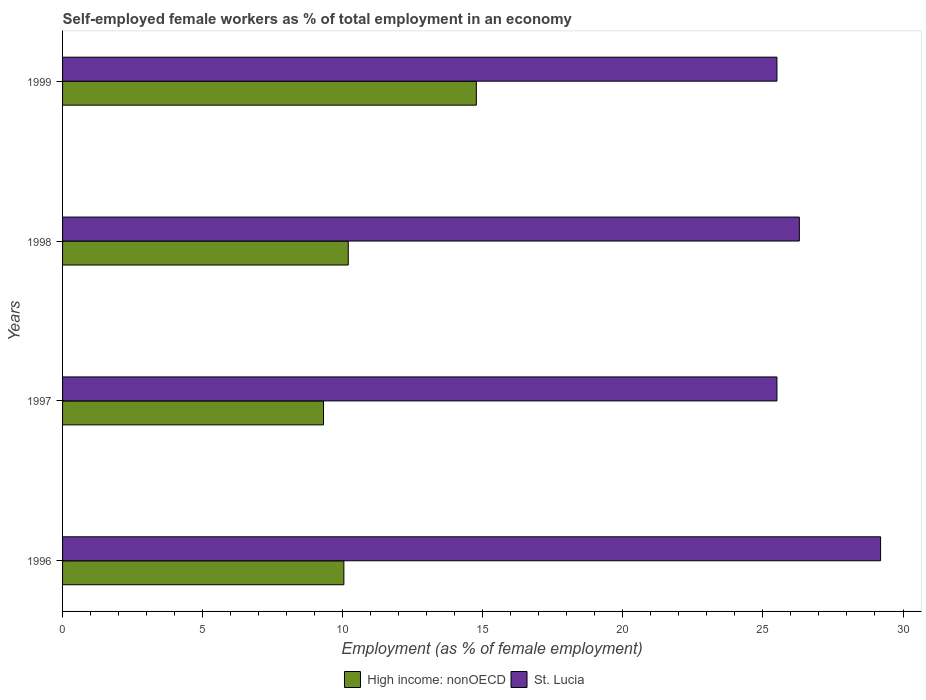How many groups of bars are there?
Ensure brevity in your answer.  4. Are the number of bars on each tick of the Y-axis equal?
Keep it short and to the point. Yes. How many bars are there on the 2nd tick from the bottom?
Give a very brief answer. 2. What is the label of the 3rd group of bars from the top?
Provide a short and direct response. 1997. What is the percentage of self-employed female workers in High income: nonOECD in 1998?
Your answer should be very brief. 10.2. Across all years, what is the maximum percentage of self-employed female workers in High income: nonOECD?
Offer a terse response. 14.77. Across all years, what is the minimum percentage of self-employed female workers in St. Lucia?
Your answer should be very brief. 25.5. What is the total percentage of self-employed female workers in High income: nonOECD in the graph?
Give a very brief answer. 44.33. What is the difference between the percentage of self-employed female workers in High income: nonOECD in 1997 and that in 1998?
Provide a succinct answer. -0.88. What is the difference between the percentage of self-employed female workers in High income: nonOECD in 1996 and the percentage of self-employed female workers in St. Lucia in 1998?
Ensure brevity in your answer.  -16.26. What is the average percentage of self-employed female workers in St. Lucia per year?
Provide a short and direct response. 26.62. In the year 1996, what is the difference between the percentage of self-employed female workers in High income: nonOECD and percentage of self-employed female workers in St. Lucia?
Make the answer very short. -19.16. In how many years, is the percentage of self-employed female workers in St. Lucia greater than 20 %?
Keep it short and to the point. 4. What is the ratio of the percentage of self-employed female workers in St. Lucia in 1996 to that in 1999?
Provide a succinct answer. 1.15. Is the difference between the percentage of self-employed female workers in High income: nonOECD in 1996 and 1999 greater than the difference between the percentage of self-employed female workers in St. Lucia in 1996 and 1999?
Give a very brief answer. No. What is the difference between the highest and the second highest percentage of self-employed female workers in St. Lucia?
Make the answer very short. 2.9. What is the difference between the highest and the lowest percentage of self-employed female workers in High income: nonOECD?
Ensure brevity in your answer.  5.46. In how many years, is the percentage of self-employed female workers in St. Lucia greater than the average percentage of self-employed female workers in St. Lucia taken over all years?
Make the answer very short. 1. Is the sum of the percentage of self-employed female workers in St. Lucia in 1998 and 1999 greater than the maximum percentage of self-employed female workers in High income: nonOECD across all years?
Make the answer very short. Yes. What does the 1st bar from the top in 1997 represents?
Make the answer very short. St. Lucia. What does the 2nd bar from the bottom in 1997 represents?
Give a very brief answer. St. Lucia. Are all the bars in the graph horizontal?
Make the answer very short. Yes. How many years are there in the graph?
Ensure brevity in your answer.  4. Does the graph contain any zero values?
Give a very brief answer. No. Does the graph contain grids?
Ensure brevity in your answer.  No. How many legend labels are there?
Your answer should be very brief. 2. How are the legend labels stacked?
Make the answer very short. Horizontal. What is the title of the graph?
Make the answer very short. Self-employed female workers as % of total employment in an economy. What is the label or title of the X-axis?
Make the answer very short. Employment (as % of female employment). What is the Employment (as % of female employment) of High income: nonOECD in 1996?
Offer a very short reply. 10.04. What is the Employment (as % of female employment) of St. Lucia in 1996?
Provide a succinct answer. 29.2. What is the Employment (as % of female employment) of High income: nonOECD in 1997?
Your response must be concise. 9.31. What is the Employment (as % of female employment) in St. Lucia in 1997?
Give a very brief answer. 25.5. What is the Employment (as % of female employment) in High income: nonOECD in 1998?
Your answer should be very brief. 10.2. What is the Employment (as % of female employment) of St. Lucia in 1998?
Give a very brief answer. 26.3. What is the Employment (as % of female employment) of High income: nonOECD in 1999?
Your answer should be compact. 14.77. What is the Employment (as % of female employment) of St. Lucia in 1999?
Offer a terse response. 25.5. Across all years, what is the maximum Employment (as % of female employment) of High income: nonOECD?
Provide a short and direct response. 14.77. Across all years, what is the maximum Employment (as % of female employment) of St. Lucia?
Provide a short and direct response. 29.2. Across all years, what is the minimum Employment (as % of female employment) in High income: nonOECD?
Keep it short and to the point. 9.31. Across all years, what is the minimum Employment (as % of female employment) in St. Lucia?
Offer a very short reply. 25.5. What is the total Employment (as % of female employment) in High income: nonOECD in the graph?
Provide a succinct answer. 44.33. What is the total Employment (as % of female employment) of St. Lucia in the graph?
Offer a very short reply. 106.5. What is the difference between the Employment (as % of female employment) of High income: nonOECD in 1996 and that in 1997?
Your answer should be very brief. 0.73. What is the difference between the Employment (as % of female employment) of High income: nonOECD in 1996 and that in 1998?
Give a very brief answer. -0.16. What is the difference between the Employment (as % of female employment) of High income: nonOECD in 1996 and that in 1999?
Your answer should be very brief. -4.73. What is the difference between the Employment (as % of female employment) of St. Lucia in 1996 and that in 1999?
Make the answer very short. 3.7. What is the difference between the Employment (as % of female employment) in High income: nonOECD in 1997 and that in 1998?
Provide a short and direct response. -0.88. What is the difference between the Employment (as % of female employment) in St. Lucia in 1997 and that in 1998?
Offer a terse response. -0.8. What is the difference between the Employment (as % of female employment) of High income: nonOECD in 1997 and that in 1999?
Your answer should be compact. -5.46. What is the difference between the Employment (as % of female employment) in St. Lucia in 1997 and that in 1999?
Offer a very short reply. 0. What is the difference between the Employment (as % of female employment) of High income: nonOECD in 1998 and that in 1999?
Keep it short and to the point. -4.57. What is the difference between the Employment (as % of female employment) of St. Lucia in 1998 and that in 1999?
Give a very brief answer. 0.8. What is the difference between the Employment (as % of female employment) of High income: nonOECD in 1996 and the Employment (as % of female employment) of St. Lucia in 1997?
Offer a terse response. -15.46. What is the difference between the Employment (as % of female employment) of High income: nonOECD in 1996 and the Employment (as % of female employment) of St. Lucia in 1998?
Offer a terse response. -16.26. What is the difference between the Employment (as % of female employment) in High income: nonOECD in 1996 and the Employment (as % of female employment) in St. Lucia in 1999?
Provide a short and direct response. -15.46. What is the difference between the Employment (as % of female employment) of High income: nonOECD in 1997 and the Employment (as % of female employment) of St. Lucia in 1998?
Keep it short and to the point. -16.99. What is the difference between the Employment (as % of female employment) in High income: nonOECD in 1997 and the Employment (as % of female employment) in St. Lucia in 1999?
Give a very brief answer. -16.19. What is the difference between the Employment (as % of female employment) in High income: nonOECD in 1998 and the Employment (as % of female employment) in St. Lucia in 1999?
Your answer should be compact. -15.3. What is the average Employment (as % of female employment) in High income: nonOECD per year?
Ensure brevity in your answer.  11.08. What is the average Employment (as % of female employment) in St. Lucia per year?
Keep it short and to the point. 26.62. In the year 1996, what is the difference between the Employment (as % of female employment) of High income: nonOECD and Employment (as % of female employment) of St. Lucia?
Your answer should be very brief. -19.16. In the year 1997, what is the difference between the Employment (as % of female employment) in High income: nonOECD and Employment (as % of female employment) in St. Lucia?
Give a very brief answer. -16.19. In the year 1998, what is the difference between the Employment (as % of female employment) of High income: nonOECD and Employment (as % of female employment) of St. Lucia?
Your response must be concise. -16.1. In the year 1999, what is the difference between the Employment (as % of female employment) in High income: nonOECD and Employment (as % of female employment) in St. Lucia?
Provide a succinct answer. -10.73. What is the ratio of the Employment (as % of female employment) in High income: nonOECD in 1996 to that in 1997?
Provide a succinct answer. 1.08. What is the ratio of the Employment (as % of female employment) in St. Lucia in 1996 to that in 1997?
Offer a terse response. 1.15. What is the ratio of the Employment (as % of female employment) in High income: nonOECD in 1996 to that in 1998?
Offer a terse response. 0.98. What is the ratio of the Employment (as % of female employment) of St. Lucia in 1996 to that in 1998?
Give a very brief answer. 1.11. What is the ratio of the Employment (as % of female employment) in High income: nonOECD in 1996 to that in 1999?
Your answer should be very brief. 0.68. What is the ratio of the Employment (as % of female employment) in St. Lucia in 1996 to that in 1999?
Offer a terse response. 1.15. What is the ratio of the Employment (as % of female employment) in High income: nonOECD in 1997 to that in 1998?
Provide a short and direct response. 0.91. What is the ratio of the Employment (as % of female employment) in St. Lucia in 1997 to that in 1998?
Offer a terse response. 0.97. What is the ratio of the Employment (as % of female employment) of High income: nonOECD in 1997 to that in 1999?
Ensure brevity in your answer.  0.63. What is the ratio of the Employment (as % of female employment) of St. Lucia in 1997 to that in 1999?
Your response must be concise. 1. What is the ratio of the Employment (as % of female employment) in High income: nonOECD in 1998 to that in 1999?
Your answer should be compact. 0.69. What is the ratio of the Employment (as % of female employment) in St. Lucia in 1998 to that in 1999?
Provide a short and direct response. 1.03. What is the difference between the highest and the second highest Employment (as % of female employment) in High income: nonOECD?
Keep it short and to the point. 4.57. What is the difference between the highest and the lowest Employment (as % of female employment) of High income: nonOECD?
Your response must be concise. 5.46. What is the difference between the highest and the lowest Employment (as % of female employment) in St. Lucia?
Offer a terse response. 3.7. 